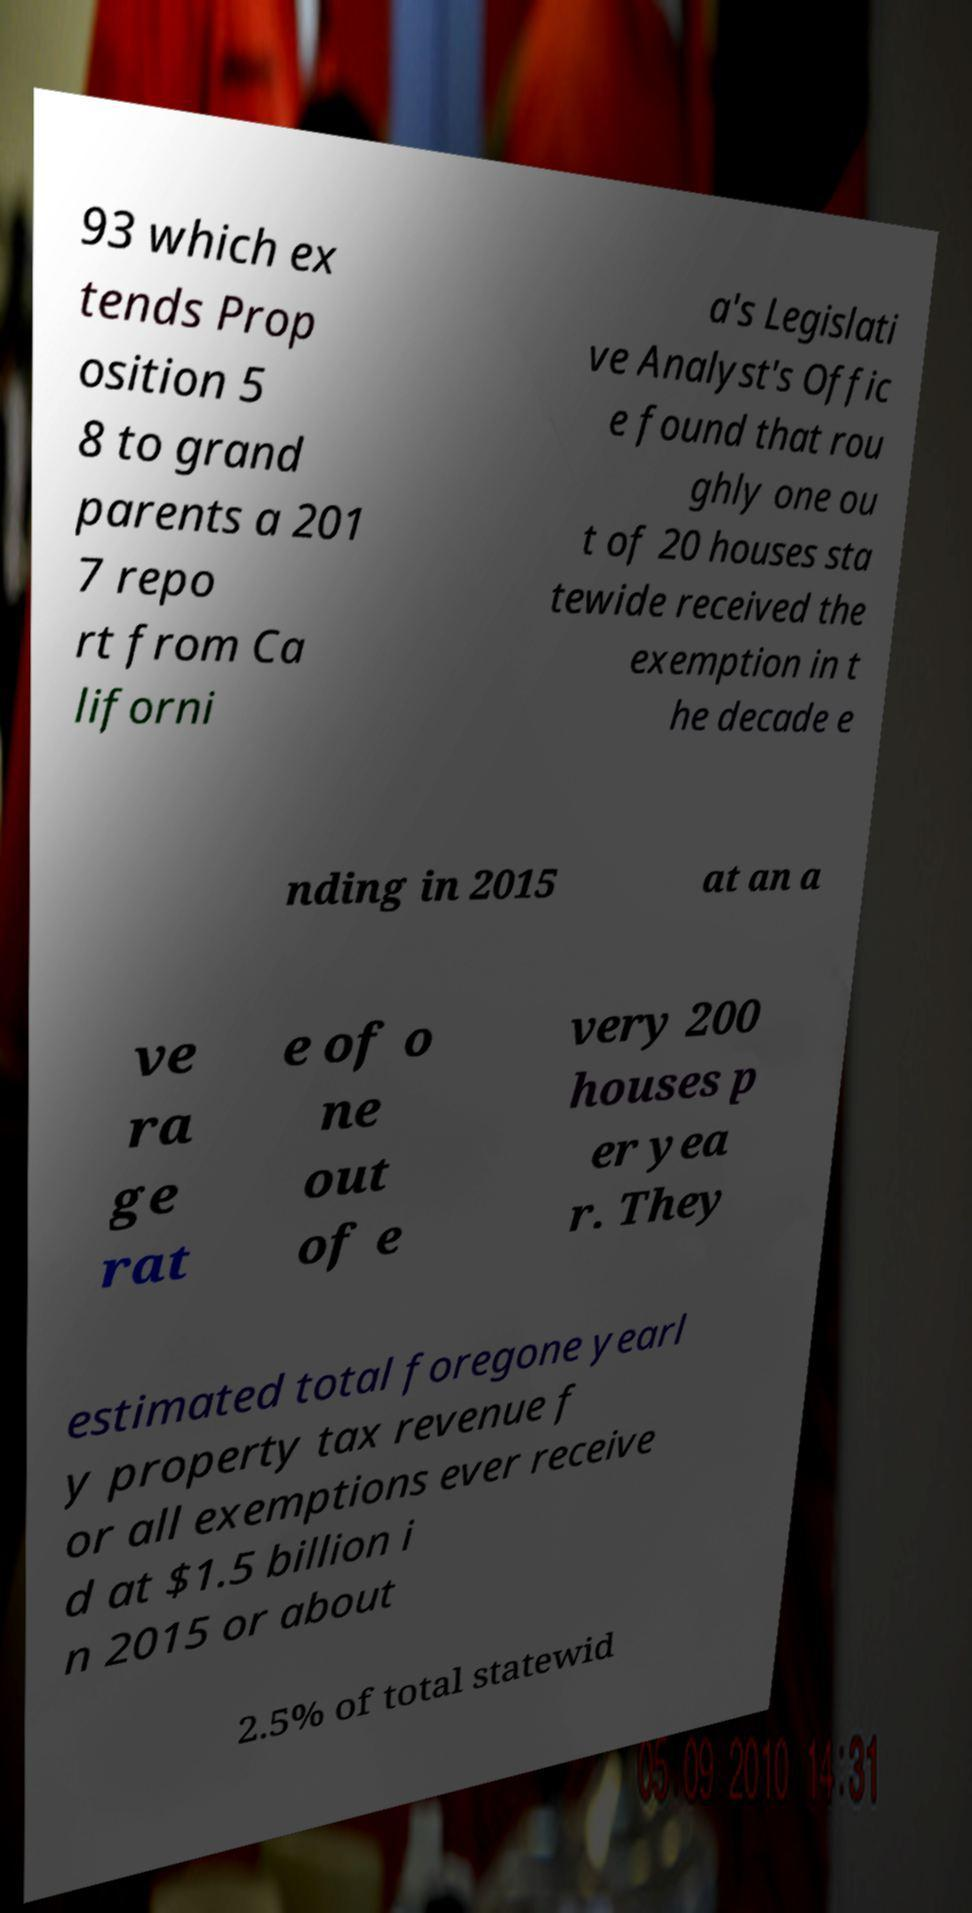Could you assist in decoding the text presented in this image and type it out clearly? 93 which ex tends Prop osition 5 8 to grand parents a 201 7 repo rt from Ca liforni a's Legislati ve Analyst's Offic e found that rou ghly one ou t of 20 houses sta tewide received the exemption in t he decade e nding in 2015 at an a ve ra ge rat e of o ne out of e very 200 houses p er yea r. They estimated total foregone yearl y property tax revenue f or all exemptions ever receive d at $1.5 billion i n 2015 or about 2.5% of total statewid 